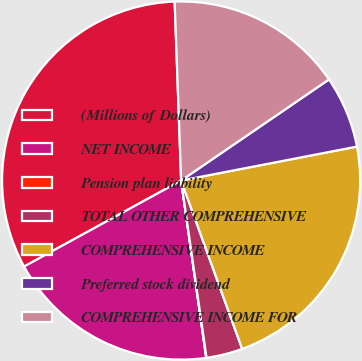<chart> <loc_0><loc_0><loc_500><loc_500><pie_chart><fcel>(Millions of Dollars)<fcel>NET INCOME<fcel>Pension plan liability<fcel>TOTAL OTHER COMPREHENSIVE<fcel>COMPREHENSIVE INCOME<fcel>Preferred stock dividend<fcel>COMPREHENSIVE INCOME FOR<nl><fcel>32.4%<fcel>19.26%<fcel>0.03%<fcel>3.27%<fcel>22.5%<fcel>6.51%<fcel>16.03%<nl></chart> 